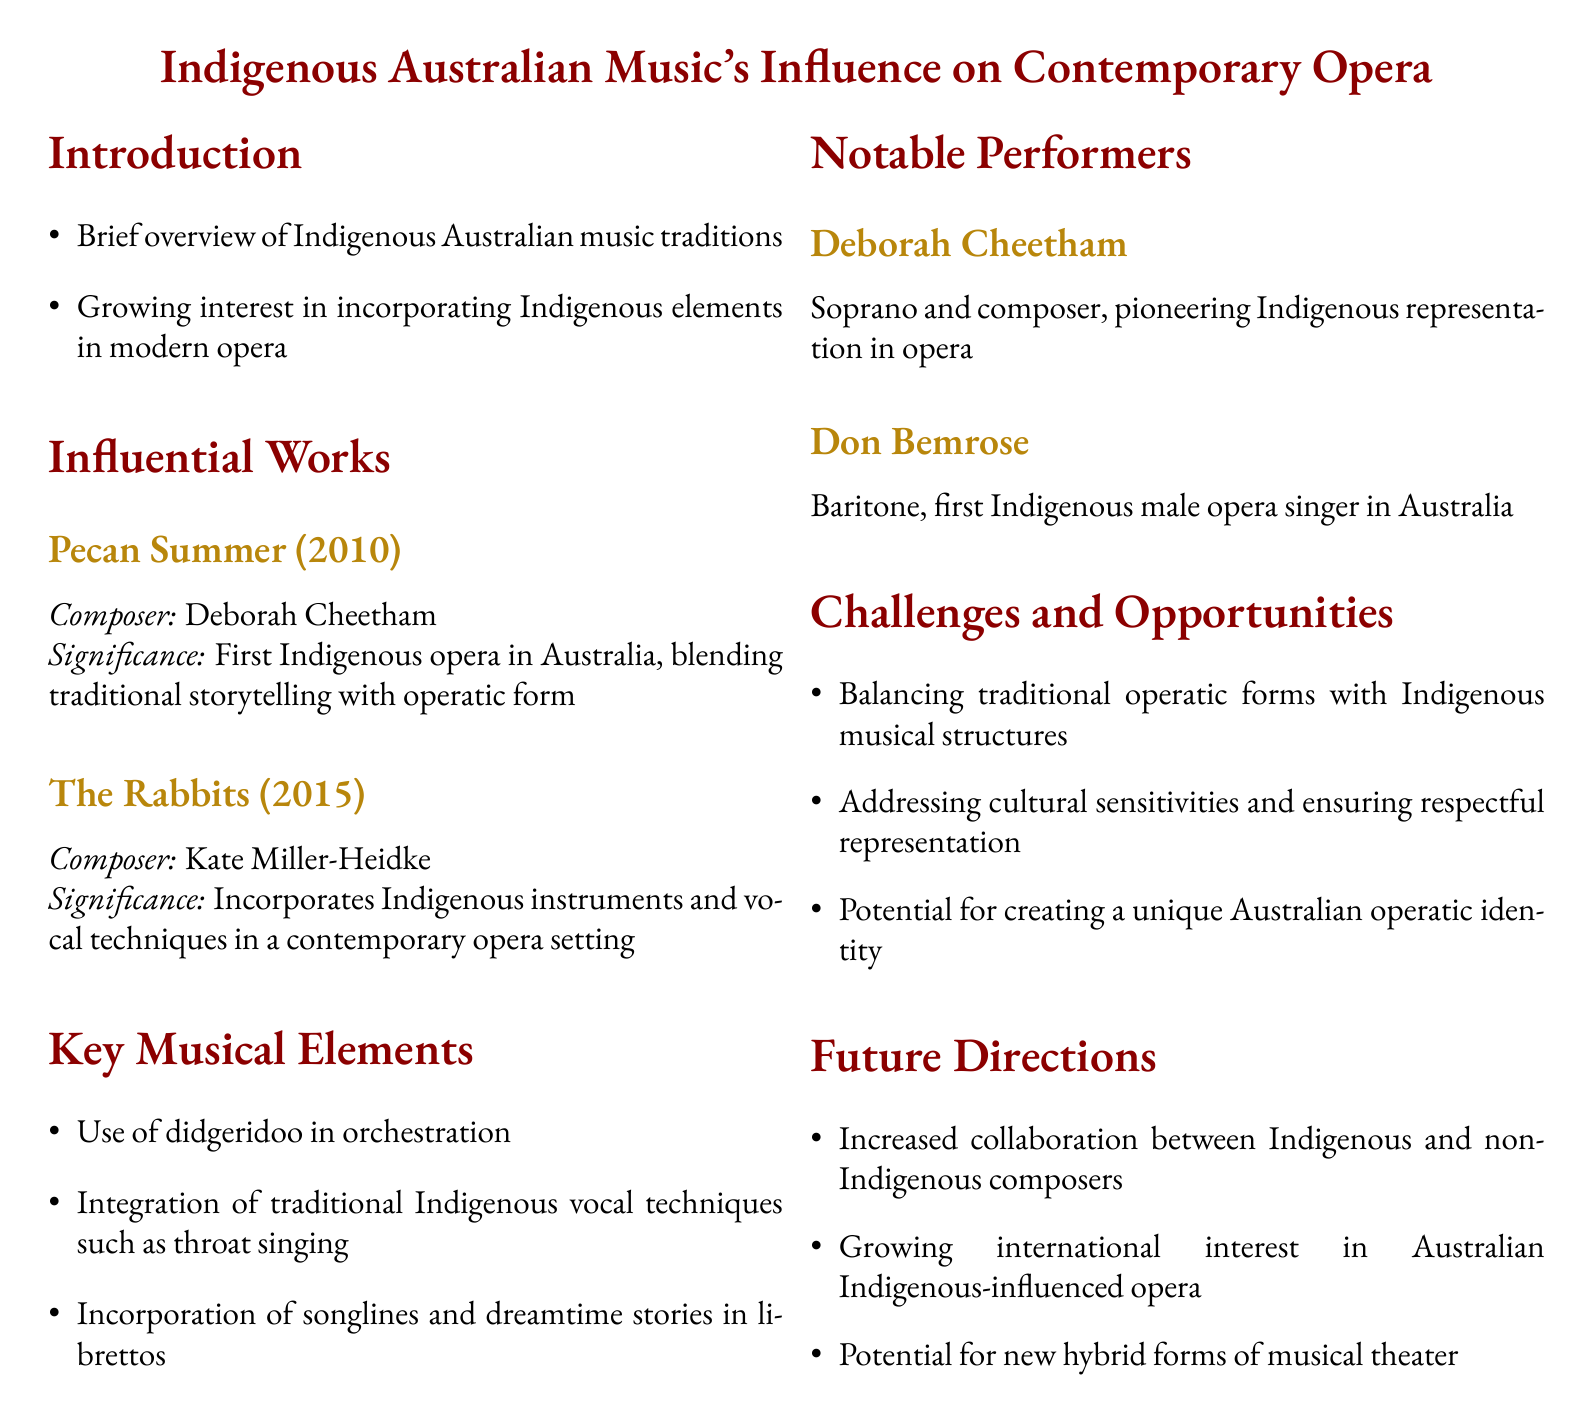What is the title of the document? The title is explicitly stated at the beginning of the document, which is "Indigenous Australian Music's Influence on Contemporary Opera."
Answer: Indigenous Australian Music's Influence on Contemporary Opera Who composed "Pecan Summer"? The document clearly attributes "Pecan Summer" to its composer, which is Deborah Cheetham.
Answer: Deborah Cheetham In what year was "The Rabbits" released? The year of release for "The Rabbits" is specifically mentioned in the document, which is 2015.
Answer: 2015 What is a key musical element mentioned in the document? The document lists several musical elements, one of which is the "Use of didgeridoo in orchestration."
Answer: Use of didgeridoo in orchestration Who is noted as the first Indigenous male opera singer in Australia? The document identifies Don Bemrose as the first Indigenous male opera singer in Australia.
Answer: Don Bemrose What challenge is mentioned regarding Indigenous music and traditional operatic forms? The document highlights a specific challenge, which is "Balancing traditional operatic forms with Indigenous musical structures."
Answer: Balancing traditional operatic forms with Indigenous musical structures What is a potential future direction for Australian opera mentioned in the document? The document discusses future possibilities, one of which is "Increased collaboration between Indigenous and non-Indigenous composers."
Answer: Increased collaboration between Indigenous and non-Indigenous composers What significant event does "Pecan Summer" represent? The significance of "Pecan Summer" is outlined as the "First Indigenous opera in Australia."
Answer: First Indigenous opera in Australia 